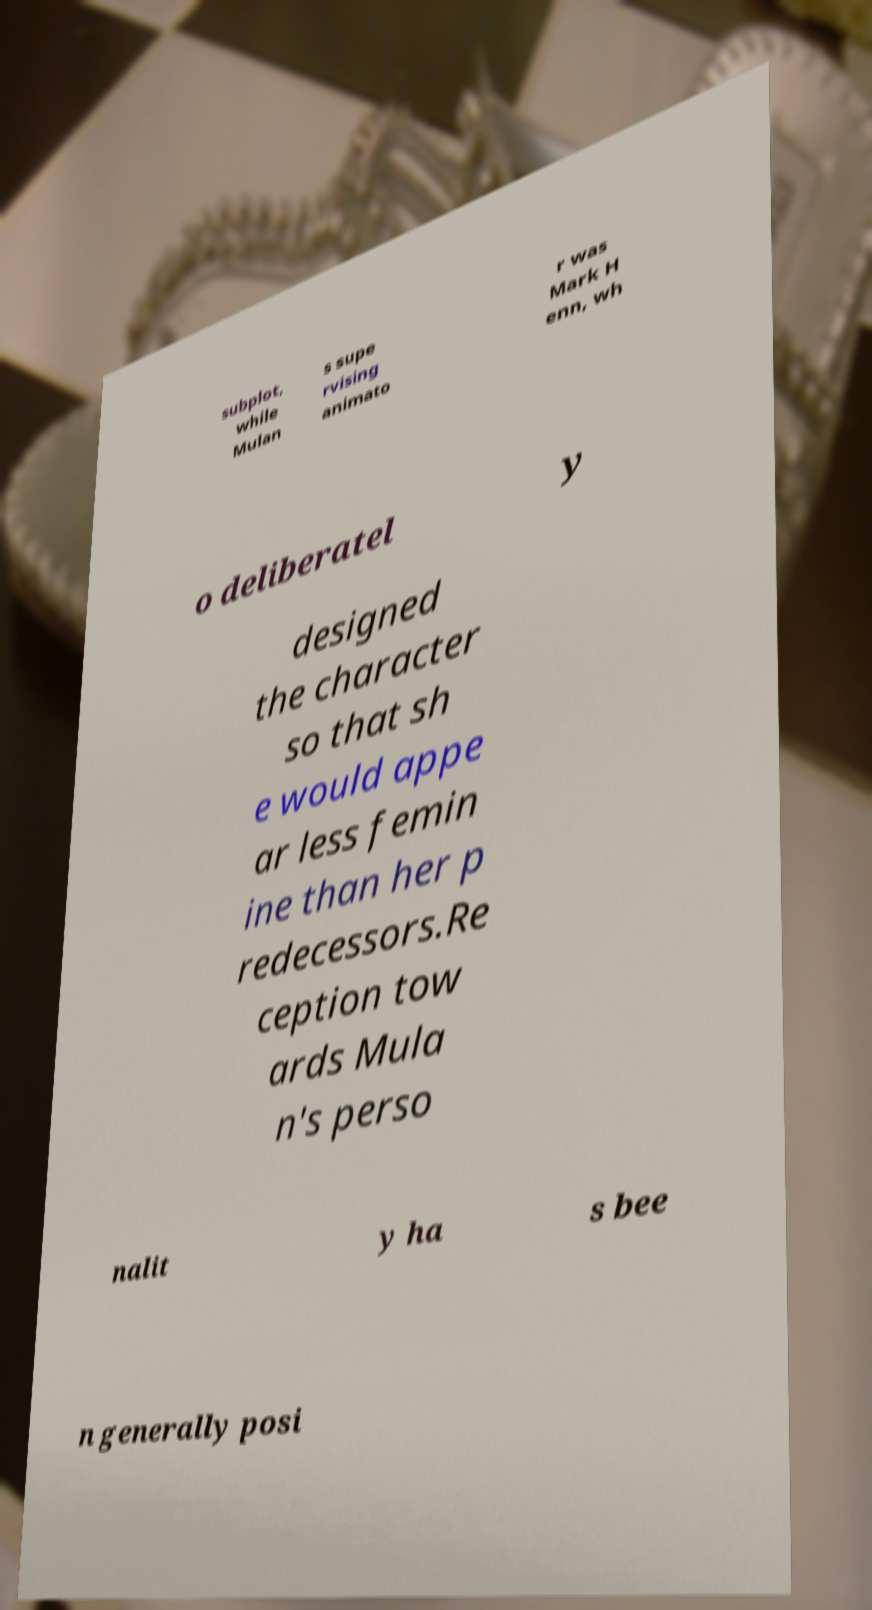Can you accurately transcribe the text from the provided image for me? subplot, while Mulan s supe rvising animato r was Mark H enn, wh o deliberatel y designed the character so that sh e would appe ar less femin ine than her p redecessors.Re ception tow ards Mula n's perso nalit y ha s bee n generally posi 